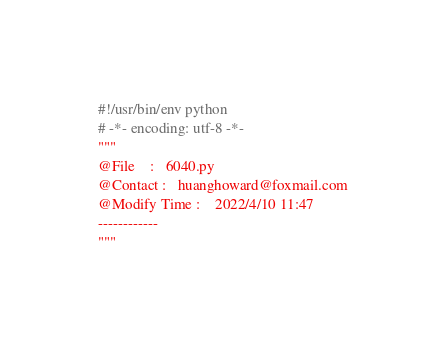Convert code to text. <code><loc_0><loc_0><loc_500><loc_500><_Python_>#!/usr/bin/env python
# -*- encoding: utf-8 -*-
"""
@File    :   6040.py    
@Contact :   huanghoward@foxmail.com
@Modify Time :    2022/4/10 11:47  
------------      
"""
</code> 